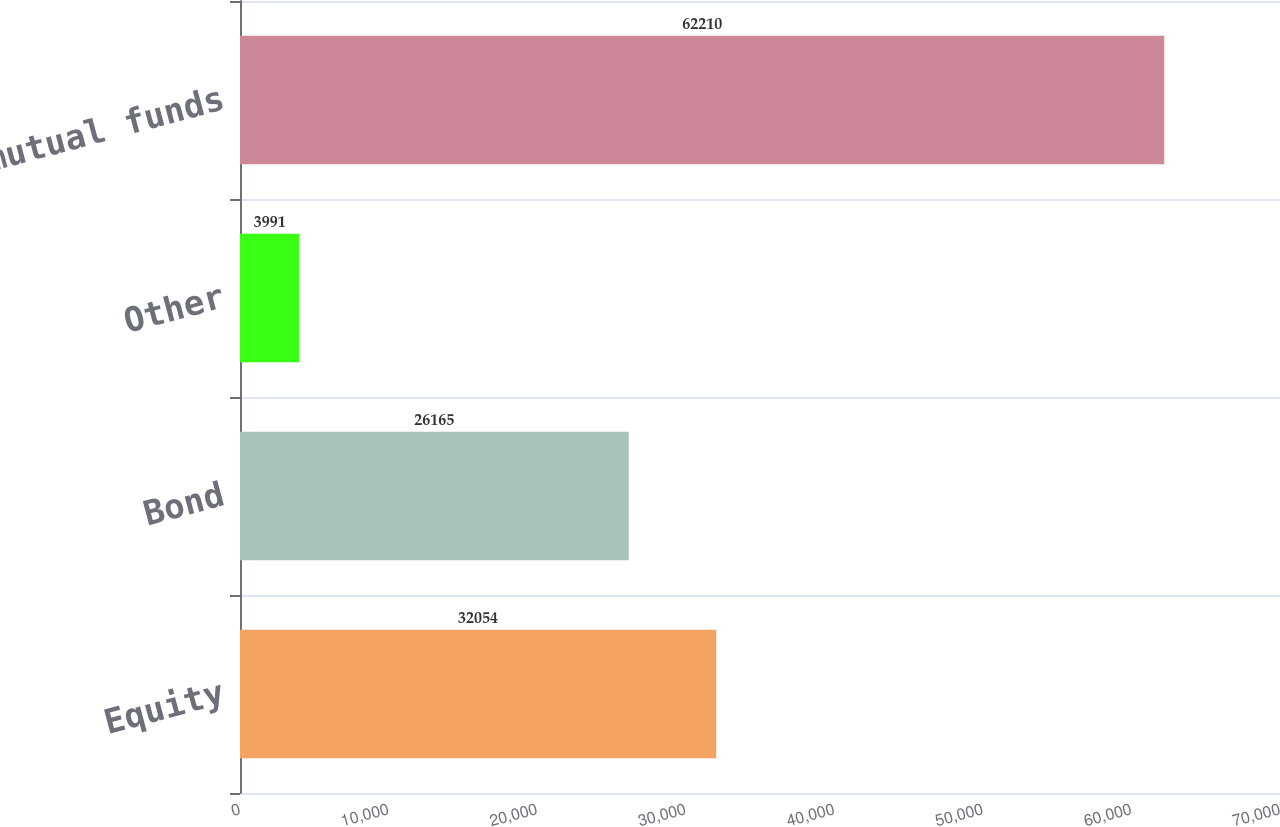Convert chart to OTSL. <chart><loc_0><loc_0><loc_500><loc_500><bar_chart><fcel>Equity<fcel>Bond<fcel>Other<fcel>Total mutual funds<nl><fcel>32054<fcel>26165<fcel>3991<fcel>62210<nl></chart> 